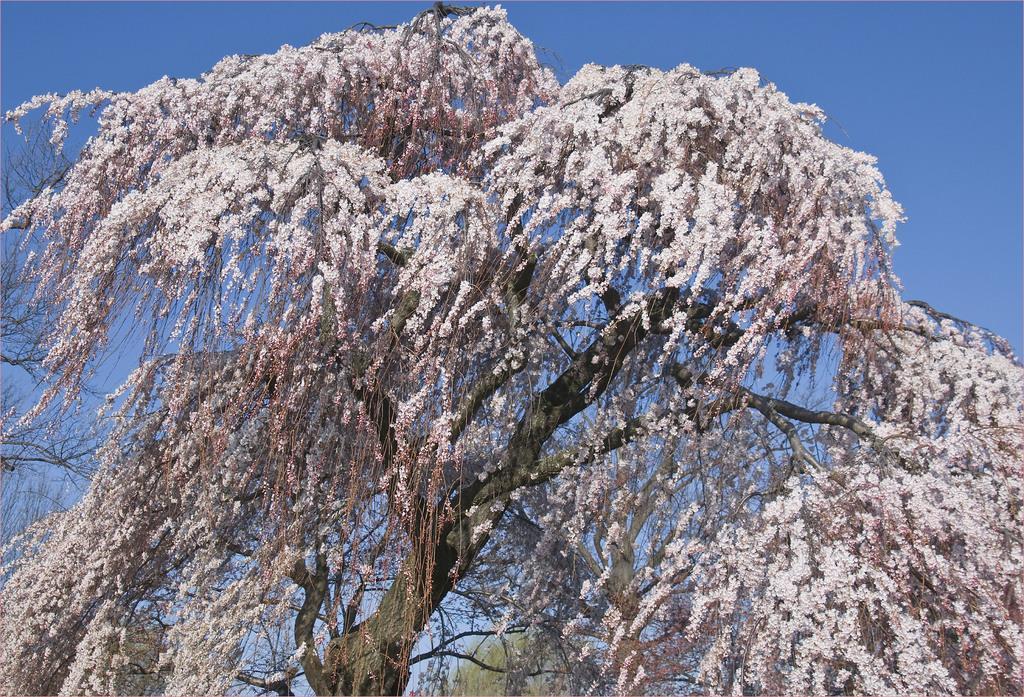In one or two sentences, can you explain what this image depicts? In this image there is a tree with flowers on it. 